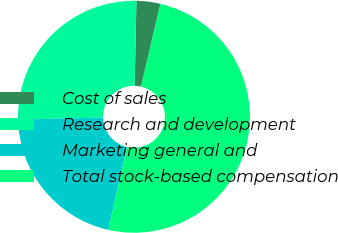Convert chart to OTSL. <chart><loc_0><loc_0><loc_500><loc_500><pie_chart><fcel>Cost of sales<fcel>Research and development<fcel>Marketing general and<fcel>Total stock-based compensation<nl><fcel>3.33%<fcel>25.72%<fcel>21.06%<fcel>49.89%<nl></chart> 